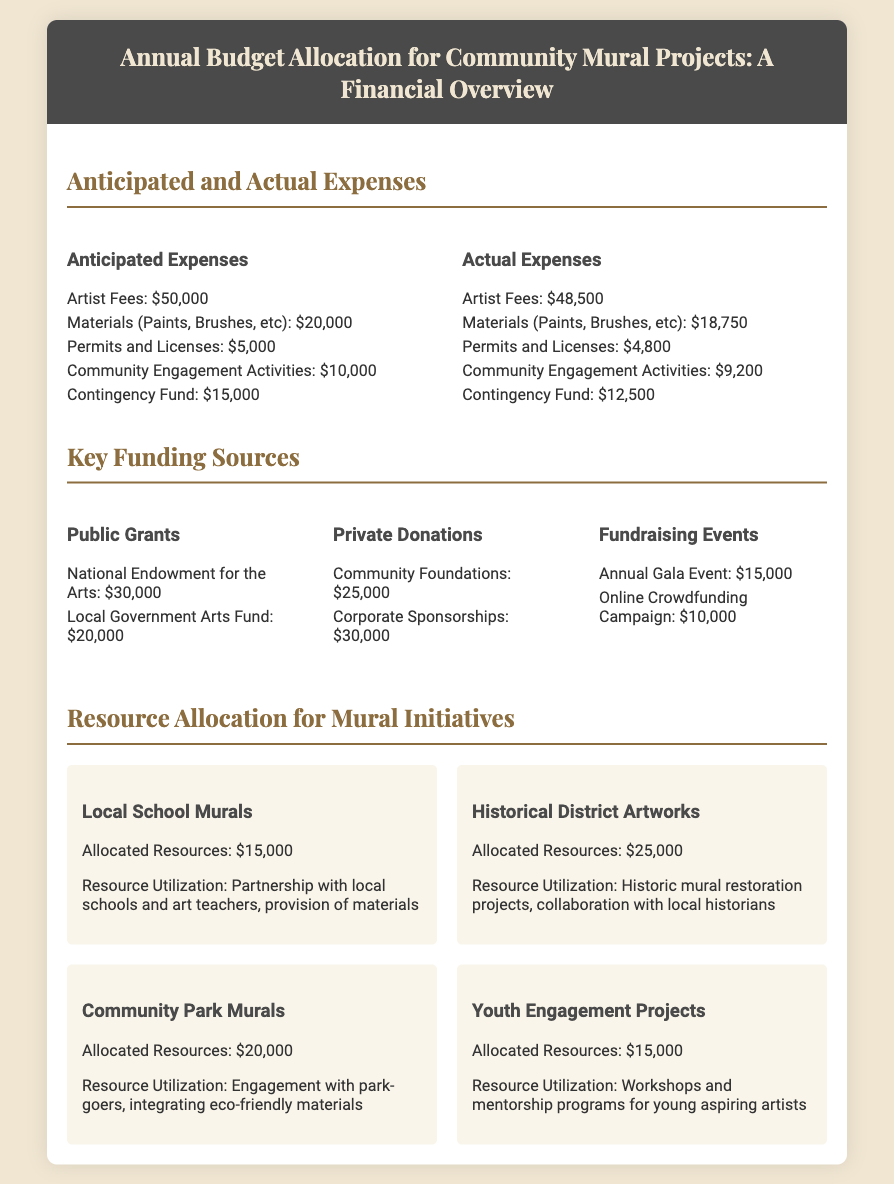what is the total anticipated expenses for community mural projects? The total anticipated expenses is calculated by adding all anticipated expenses listed in the document: $50,000 + $20,000 + $5,000 + $10,000 + $15,000 = $100,000.
Answer: $100,000 what is the amount received from Corporate Sponsorships? Corporate Sponsorships are listed under private donations, and the amount is $30,000.
Answer: $30,000 how much was spent on Community Engagement Activities? The actual expenses for Community Engagement Activities is detailed in the document as $9,200.
Answer: $9,200 which mural initiative received the highest allocation of resources? The Historical District Artworks received the highest allocation of resources at $25,000.
Answer: Historical District Artworks what is the difference between anticipated and actual expenses for materials? The difference is calculated by subtracting actual expenses ($18,750) from anticipated expenses ($20,000), which is $20,000 - $18,750 = $1,250.
Answer: $1,250 how many funding sources are listed in the document? The document lists three types of funding sources: Public Grants, Private Donations, and Fundraising Events.
Answer: Three what is the allocated resource for Youth Engagement Projects? The allocated resource for Youth Engagement Projects is noted as $15,000.
Answer: $15,000 which category contributed the amount of $30,000? The amount of $30,000 is attributed to the National Endowment for the Arts listed under Public Grants.
Answer: National Endowment for the Arts what is the purpose of the Contingency Fund? The Contingency Fund is utilized as a financial safety net for unexpected expenses, as indicated in the anticipated expenses section.
Answer: Financial safety net 